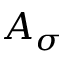<formula> <loc_0><loc_0><loc_500><loc_500>A _ { \sigma }</formula> 